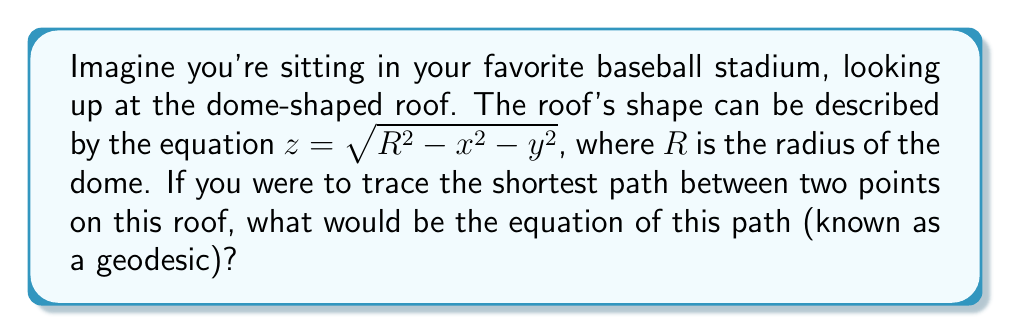Can you answer this question? Let's approach this step-by-step:

1) The dome-shaped roof is actually a hemisphere, described by the equation $z = \sqrt{R^2 - x^2 - y^2}$.

2) To find the geodesics on this surface, we need to use the Euler-Lagrange equations from the calculus of variations.

3) The arc length element on this surface is given by:

   $$ds^2 = dx^2 + dy^2 + dz^2 = dx^2 + dy^2 + \frac{x^2dx^2 + y^2dy^2 + 2xydxdy}{R^2 - x^2 - y^2}$$

4) We can simplify this by using polar coordinates $(r, \theta)$ in the $xy$-plane:
   
   $$x = r\cos\theta, \quad y = r\sin\theta$$

5) The arc length element becomes:

   $$ds^2 = \frac{R^2}{R^2 - r^2}dr^2 + r^2d\theta^2$$

6) The Lagrangian for this problem is:

   $$L = \sqrt{\frac{R^2}{R^2 - r^2}\left(\frac{dr}{d\theta}\right)^2 + r^2}$$

7) The Euler-Lagrange equation for this Lagrangian gives us:

   $$\frac{d}{d\theta}\left(\frac{\partial L}{\partial r'}\right) - \frac{\partial L}{\partial r} = 0$$

8) Solving this equation is complex, but it leads to a simple result: the geodesics are great circles on the hemisphere.

9) In the original $(x,y,z)$ coordinates, the equation of a great circle is:

   $$ax + by + cz = 0$$

   where $a^2 + b^2 + c^2 = 1$ and $(a,b,c)$ is the normal vector to the plane containing the great circle.

10) Substituting the equation of the hemisphere, we get:

    $$ax + by + c\sqrt{R^2 - x^2 - y^2} = 0$$

This is the equation of the geodesics on the dome-shaped roof.
Answer: $ax + by + c\sqrt{R^2 - x^2 - y^2} = 0$, where $a^2 + b^2 + c^2 = 1$ 